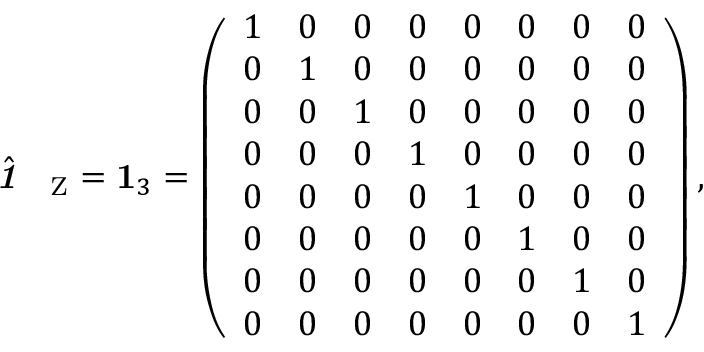Convert formula to latex. <formula><loc_0><loc_0><loc_500><loc_500>\hat { 1 \, } _ { \mathrm Z } = 1 _ { 3 } = \left ( \begin{array} { l l l l l l l l } { 1 } & { 0 } & { 0 } & { 0 } & { 0 } & { 0 } & { 0 } & { 0 } \\ { 0 } & { 1 } & { 0 } & { 0 } & { 0 } & { 0 } & { 0 } & { 0 } \\ { 0 } & { 0 } & { 1 } & { 0 } & { 0 } & { 0 } & { 0 } & { 0 } \\ { 0 } & { 0 } & { 0 } & { 1 } & { 0 } & { 0 } & { 0 } & { 0 } \\ { 0 } & { 0 } & { 0 } & { 0 } & { 1 } & { 0 } & { 0 } & { 0 } \\ { 0 } & { 0 } & { 0 } & { 0 } & { 0 } & { 1 } & { 0 } & { 0 } \\ { 0 } & { 0 } & { 0 } & { 0 } & { 0 } & { 0 } & { 1 } & { 0 } \\ { 0 } & { 0 } & { 0 } & { 0 } & { 0 } & { 0 } & { 0 } & { 1 } \end{array} \right ) ,</formula> 